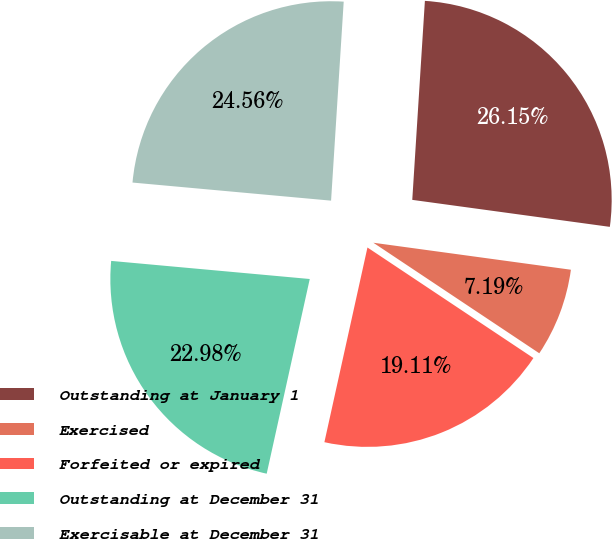Convert chart to OTSL. <chart><loc_0><loc_0><loc_500><loc_500><pie_chart><fcel>Outstanding at January 1<fcel>Exercised<fcel>Forfeited or expired<fcel>Outstanding at December 31<fcel>Exercisable at December 31<nl><fcel>26.15%<fcel>7.19%<fcel>19.11%<fcel>22.98%<fcel>24.56%<nl></chart> 